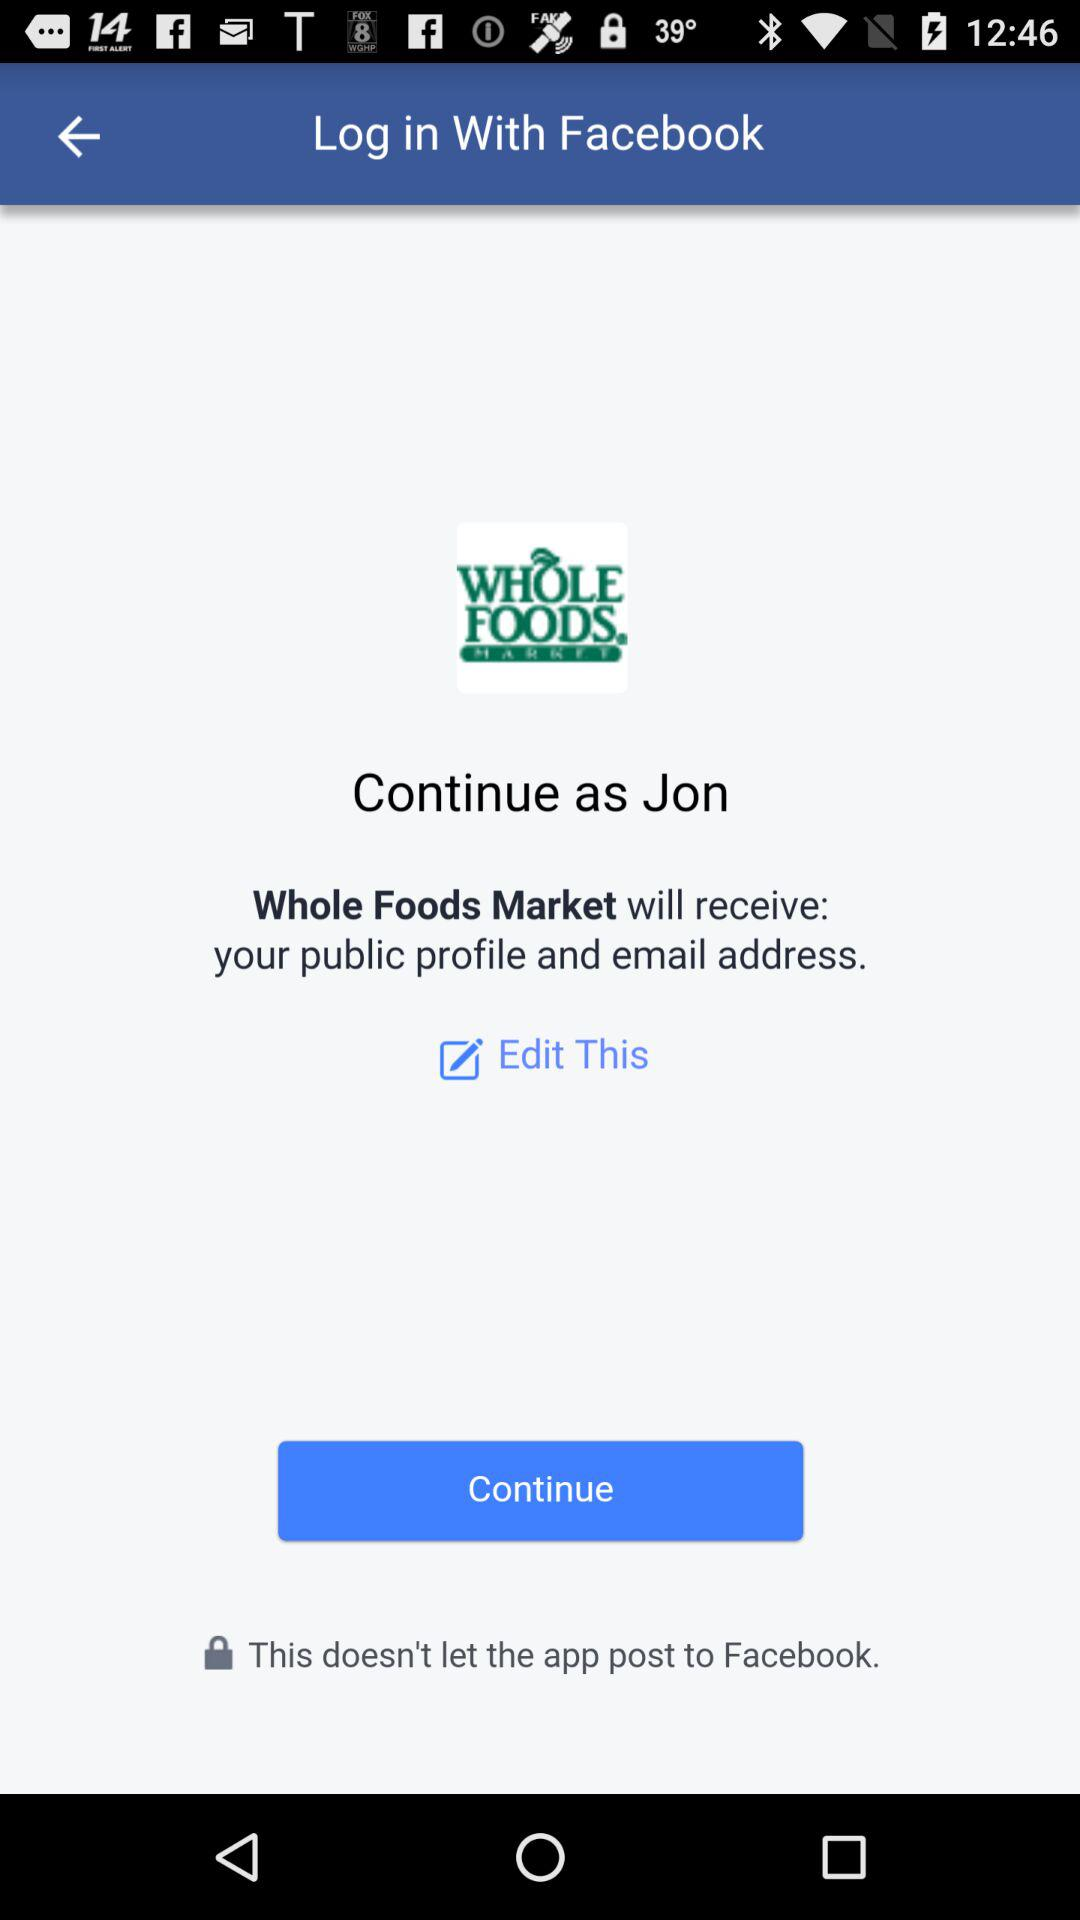What application will receive the public profile and email address? The application that will receive the public profile and email address is "Whole Foods Market". 